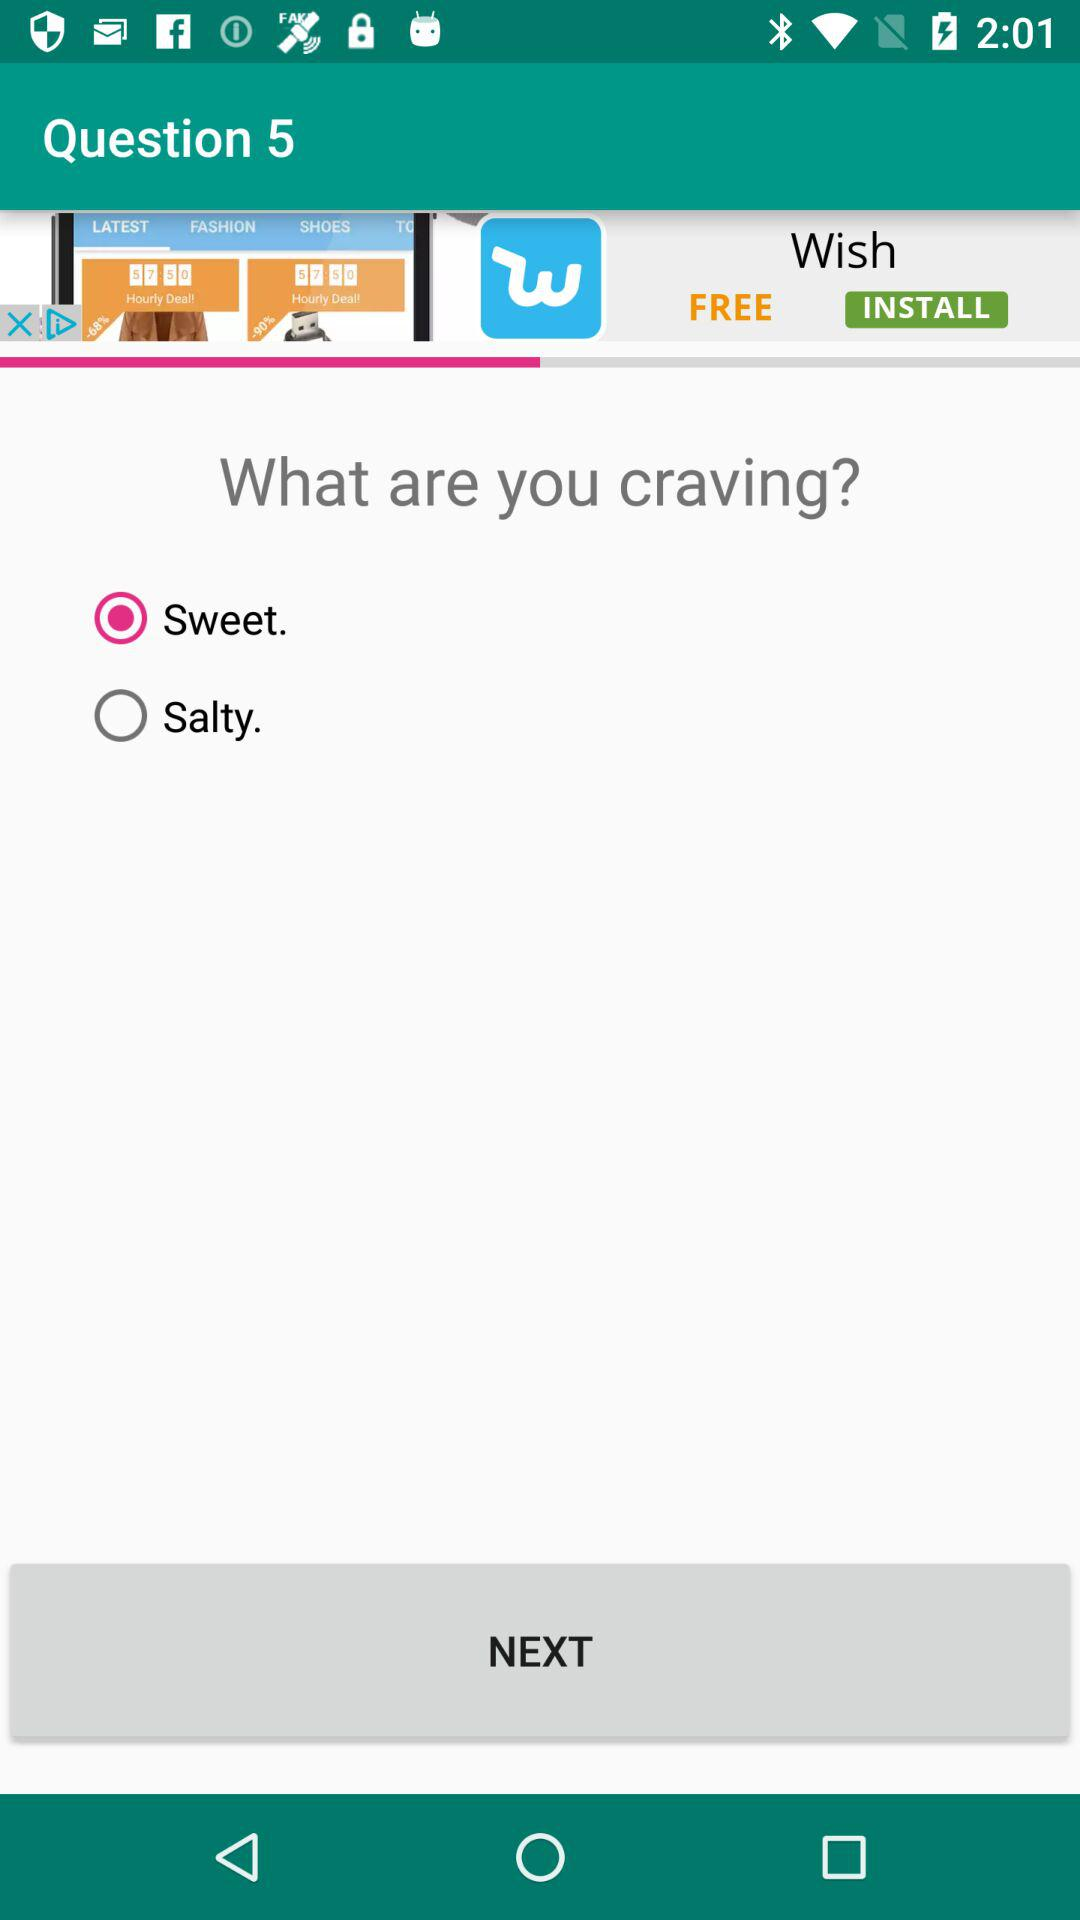Is "Salty" selected or not? It is not selected. 